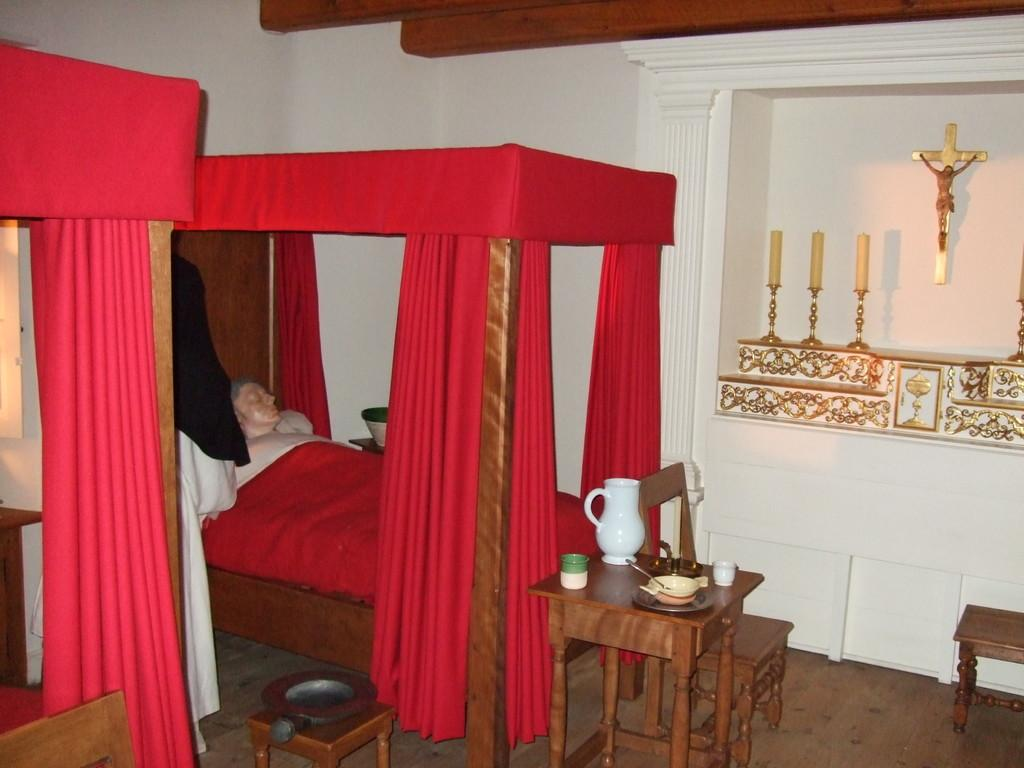What type of furniture is present in the image? There is a bed, a table, and chairs in the image. Who or what can be seen in the image? There is a person in the image. What type of window treatment is present in the image? There are curtains in the image. What is on the table in the image? There are objects on the table in the image. What type of cart is being used by the servant to teach the person in the image? There is no cart, servant, or teaching activity present in the image. 